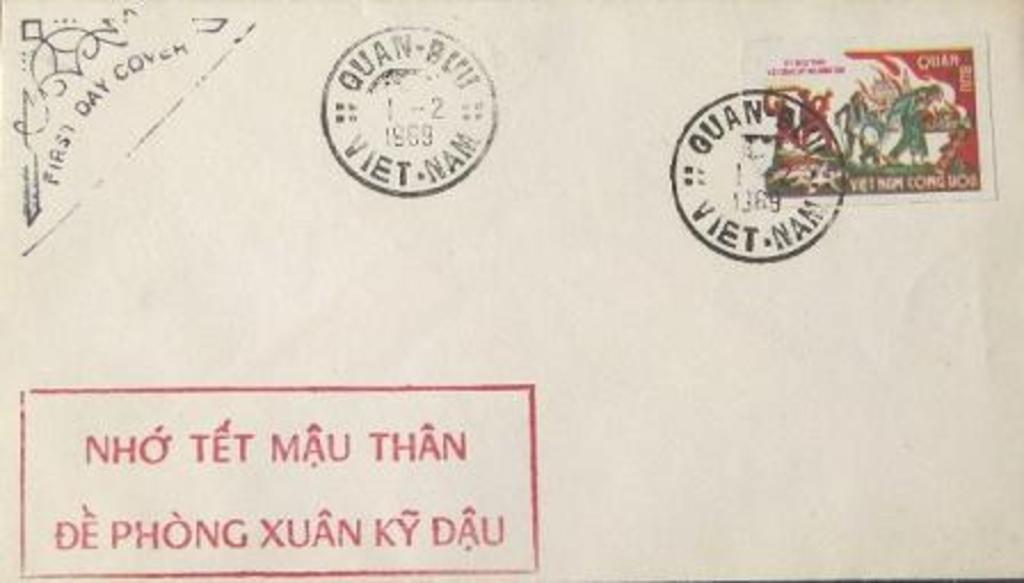<image>
Give a short and clear explanation of the subsequent image. A beige envelope with several stamps on it with two reading 1969. 